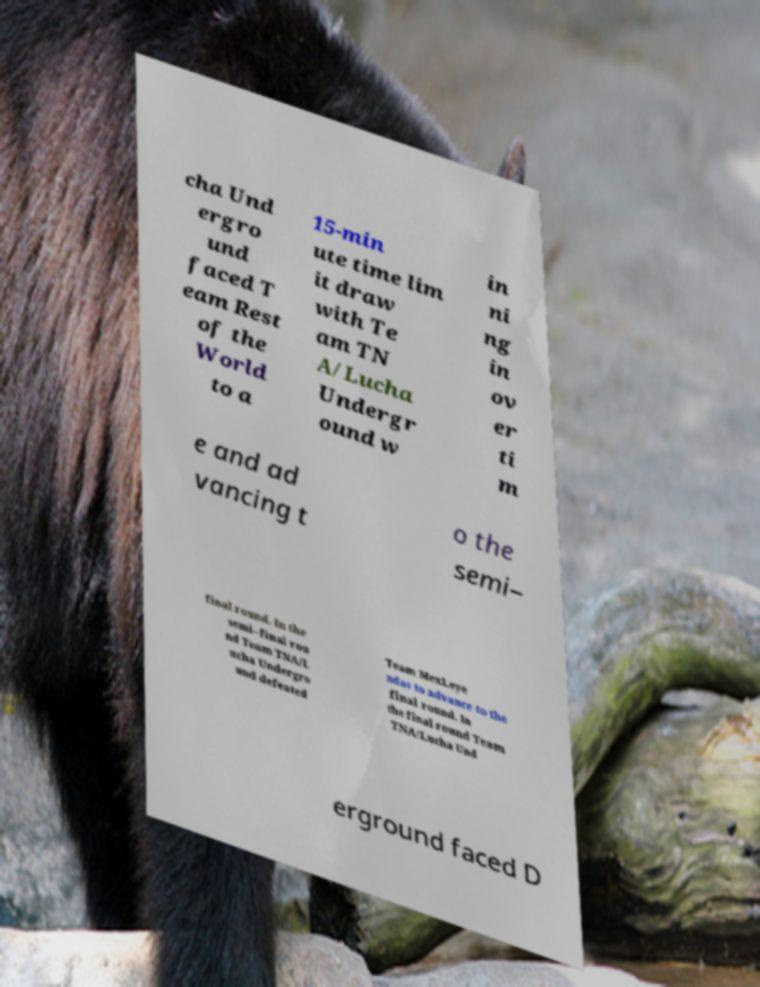What messages or text are displayed in this image? I need them in a readable, typed format. cha Und ergro und faced T eam Rest of the World to a 15-min ute time lim it draw with Te am TN A/Lucha Undergr ound w in ni ng in ov er ti m e and ad vancing t o the semi– final round. In the semi–final rou nd Team TNA/L ucha Undergro und defeated Team MexLeye ndas to advance to the final round. In the final round Team TNA/Lucha Und erground faced D 